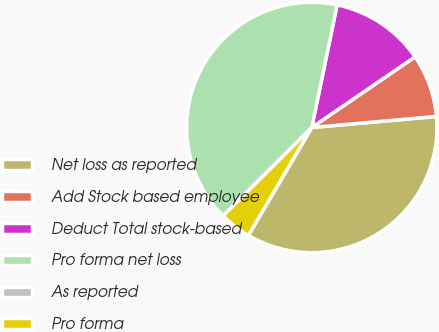<chart> <loc_0><loc_0><loc_500><loc_500><pie_chart><fcel>Net loss as reported<fcel>Add Stock based employee<fcel>Deduct Total stock-based<fcel>Pro forma net loss<fcel>As reported<fcel>Pro forma<nl><fcel>34.86%<fcel>8.14%<fcel>12.21%<fcel>40.71%<fcel>0.0%<fcel>4.07%<nl></chart> 